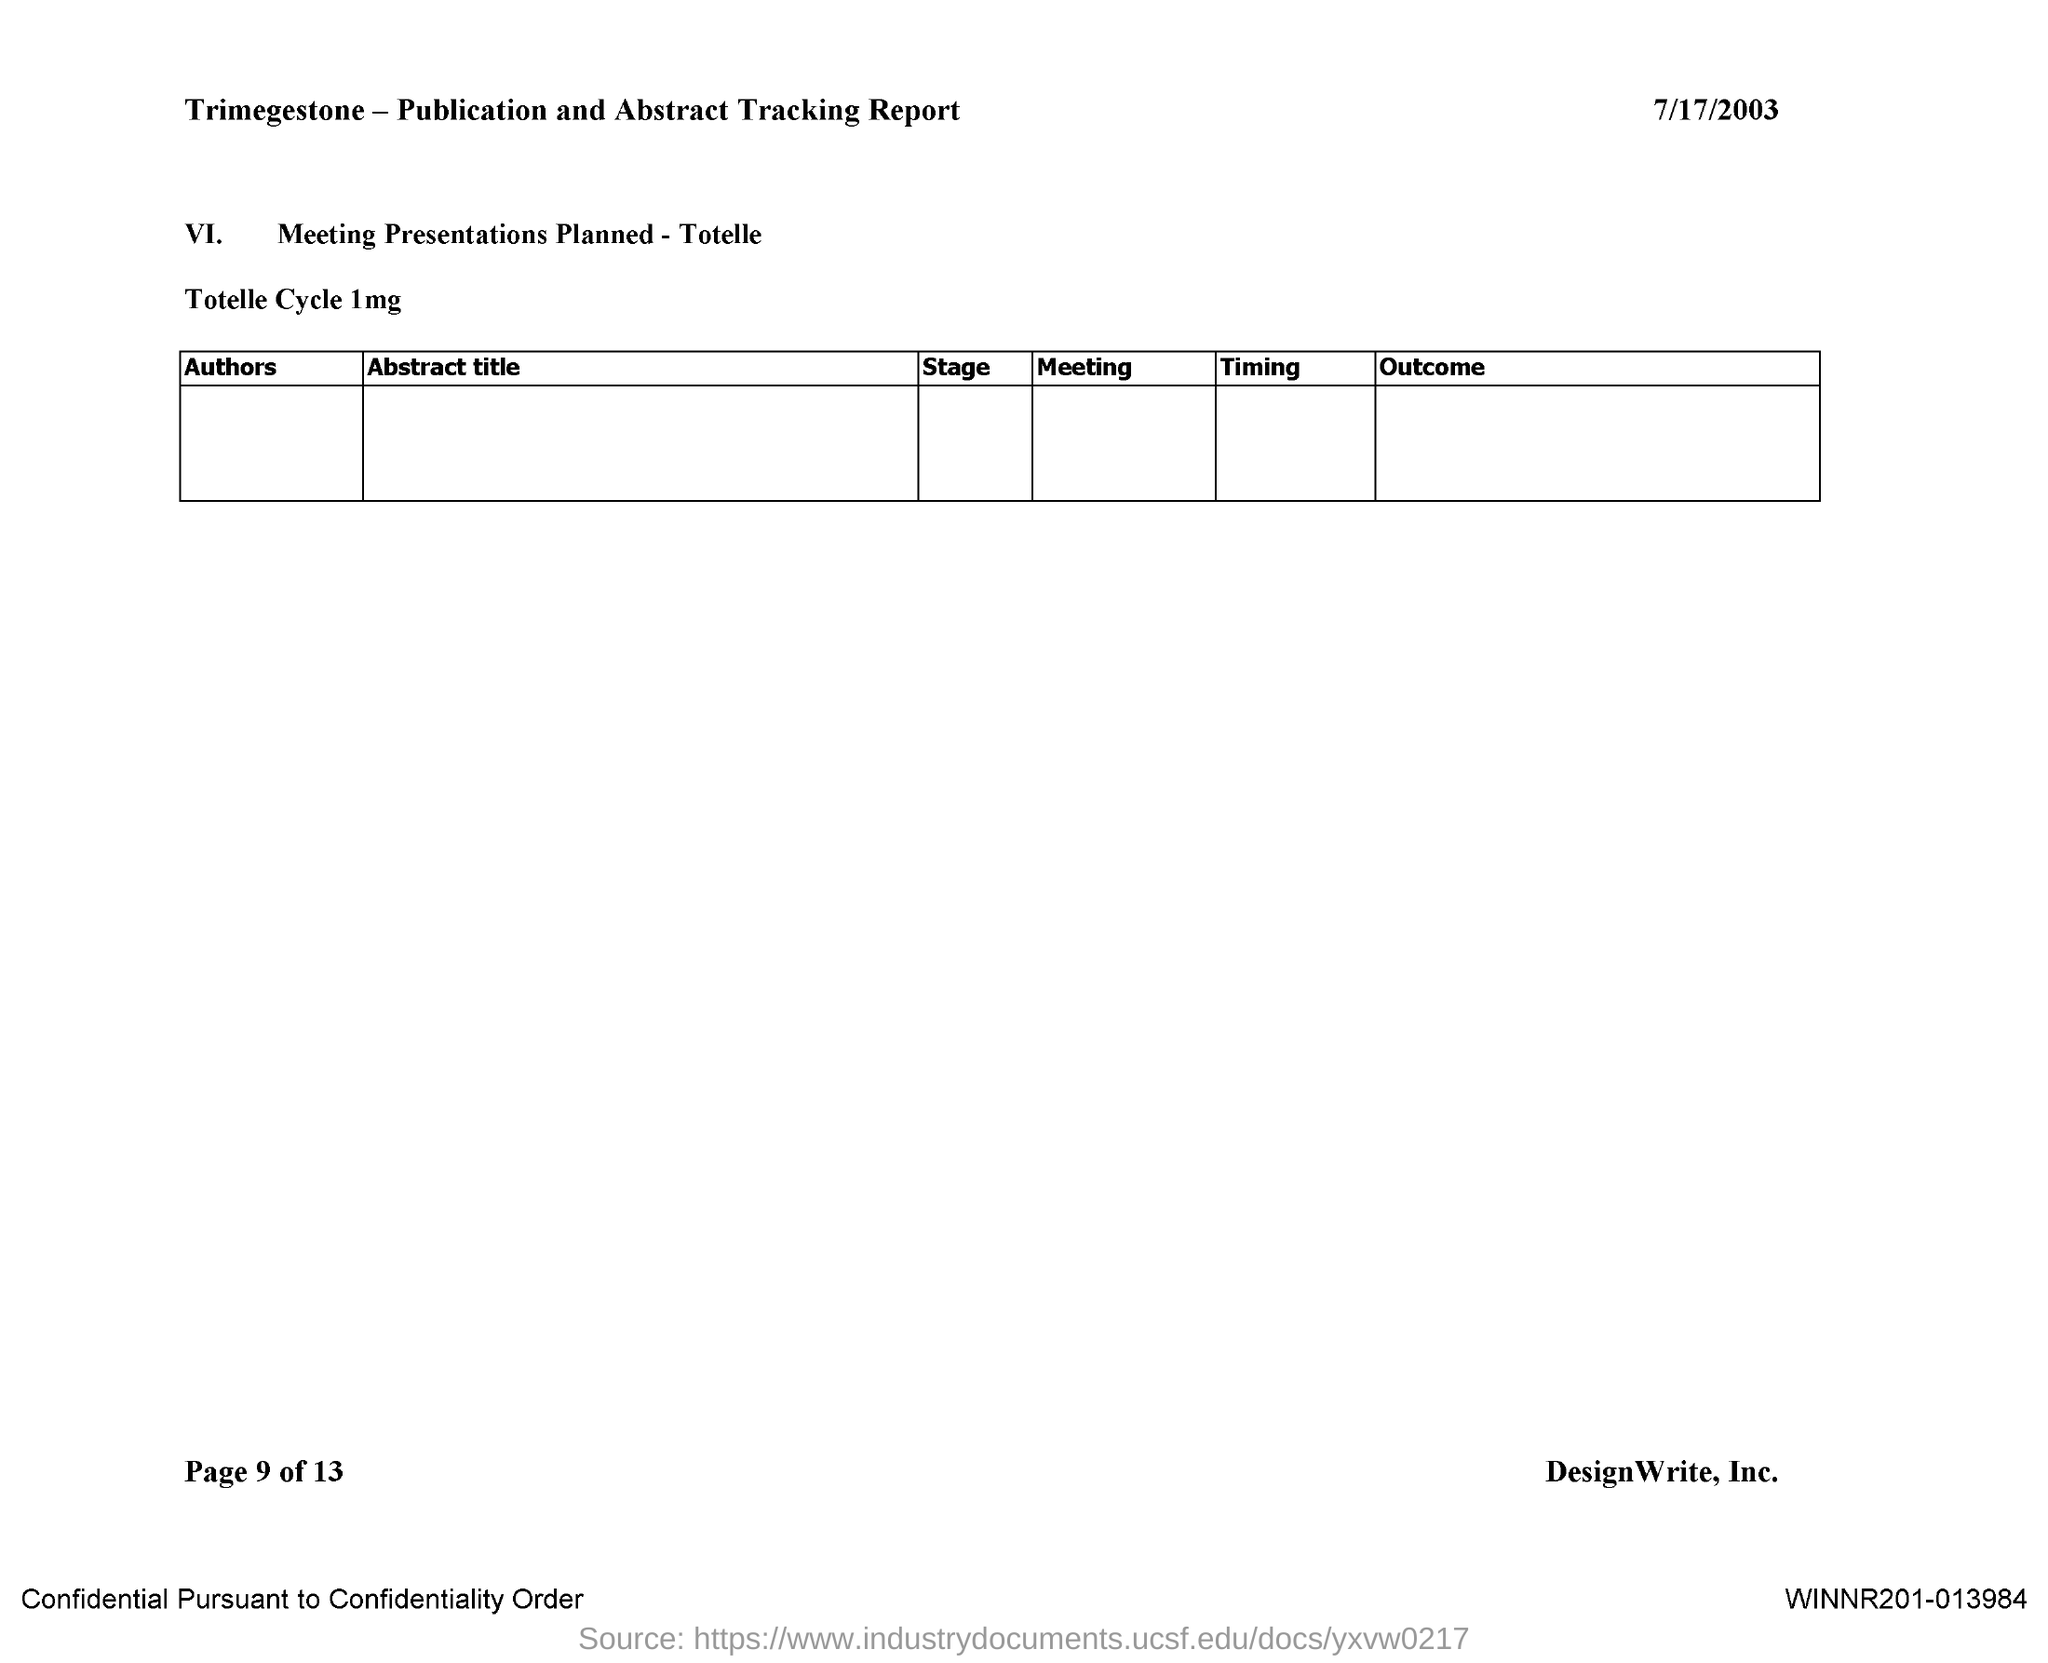Mention a couple of crucial points in this snapshot. The date on the document is July 17, 2003. 